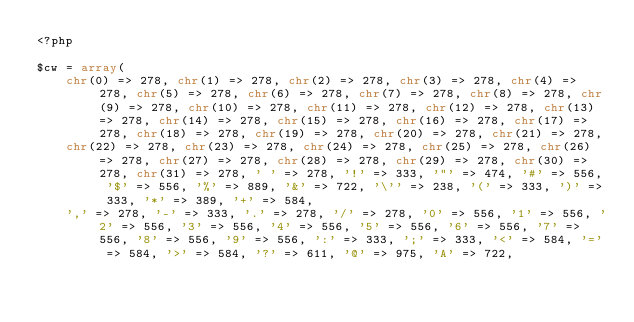Convert code to text. <code><loc_0><loc_0><loc_500><loc_500><_PHP_><?php

$cw = array(
    chr(0) => 278, chr(1) => 278, chr(2) => 278, chr(3) => 278, chr(4) => 278, chr(5) => 278, chr(6) => 278, chr(7) => 278, chr(8) => 278, chr(9) => 278, chr(10) => 278, chr(11) => 278, chr(12) => 278, chr(13) => 278, chr(14) => 278, chr(15) => 278, chr(16) => 278, chr(17) => 278, chr(18) => 278, chr(19) => 278, chr(20) => 278, chr(21) => 278,
    chr(22) => 278, chr(23) => 278, chr(24) => 278, chr(25) => 278, chr(26) => 278, chr(27) => 278, chr(28) => 278, chr(29) => 278, chr(30) => 278, chr(31) => 278, ' ' => 278, '!' => 333, '"' => 474, '#' => 556, '$' => 556, '%' => 889, '&' => 722, '\'' => 238, '(' => 333, ')' => 333, '*' => 389, '+' => 584,
    ',' => 278, '-' => 333, '.' => 278, '/' => 278, '0' => 556, '1' => 556, '2' => 556, '3' => 556, '4' => 556, '5' => 556, '6' => 556, '7' => 556, '8' => 556, '9' => 556, ':' => 333, ';' => 333, '<' => 584, '=' => 584, '>' => 584, '?' => 611, '@' => 975, 'A' => 722,</code> 